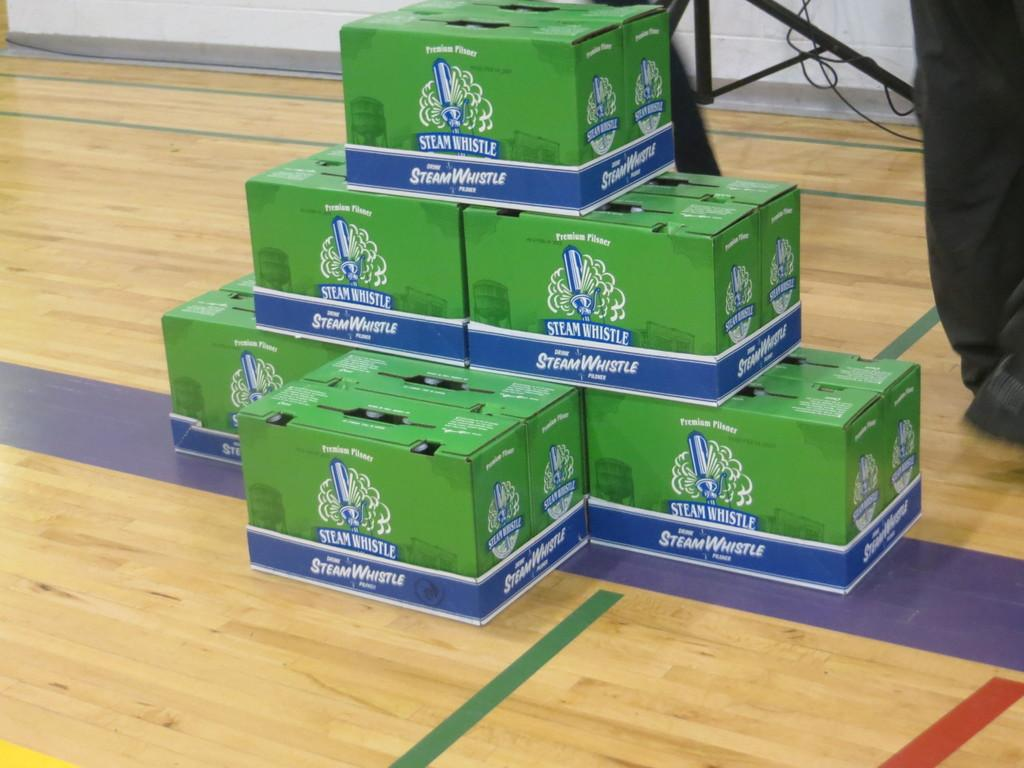Provide a one-sentence caption for the provided image. 6 boxes of steam whistle beer on the floor. 